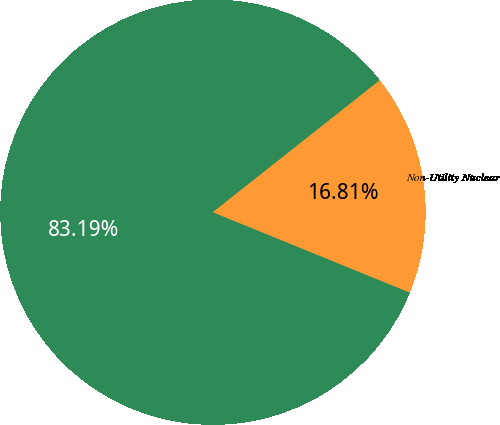Convert chart. <chart><loc_0><loc_0><loc_500><loc_500><pie_chart><fcel>U S Utility<fcel>Non-Utility Nuclear<nl><fcel>83.19%<fcel>16.81%<nl></chart> 